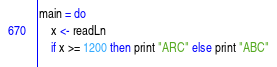Convert code to text. <code><loc_0><loc_0><loc_500><loc_500><_Haskell_>main = do
    x <- readLn
    if x >= 1200 then print "ARC" else print "ABC"</code> 